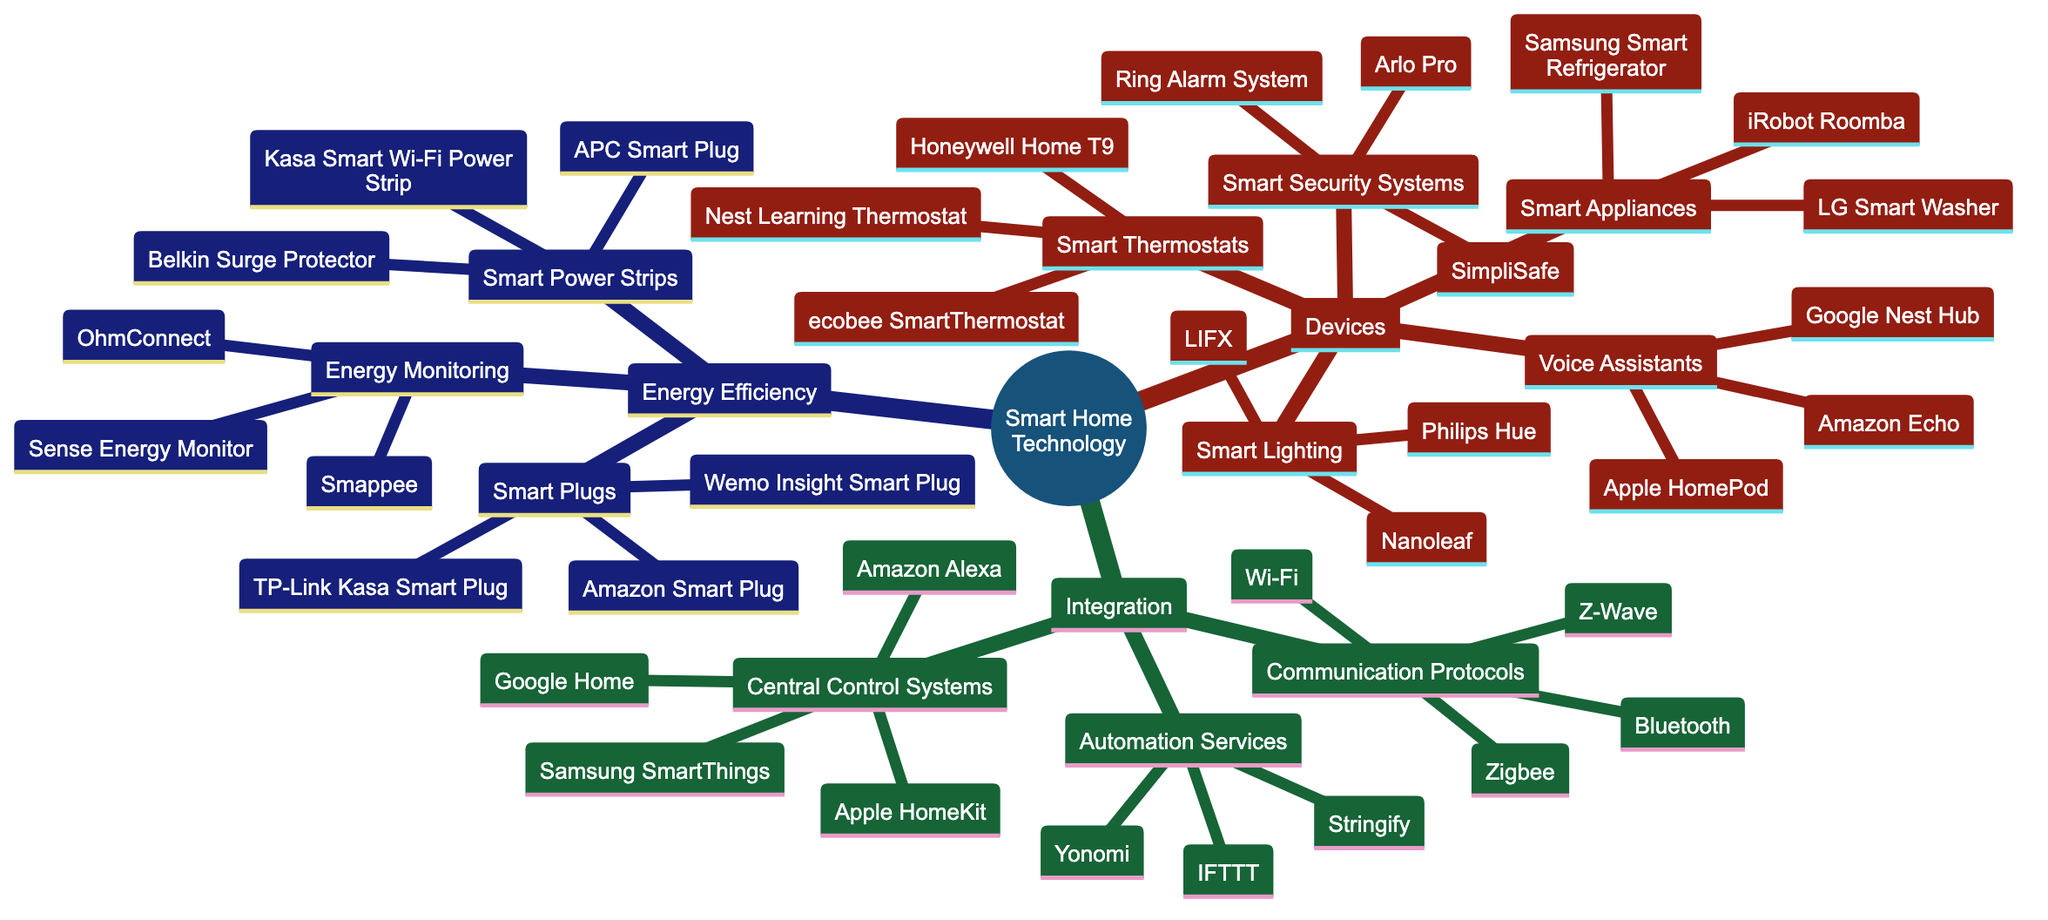What types of devices are listed under Smart Home Technology? The diagram has a main branch labeled 'Devices,' which includes categories like Smart Lighting, Smart Thermostats, Smart Security Systems, Smart Appliances, and Voice Assistants.
Answer: Smart Lighting, Smart Thermostats, Smart Security Systems, Smart Appliances, Voice Assistants How many brands are listed under Smart Lighting? Under the Smart Lighting branch, there are three devices mentioned: Philips Hue, LIFX, and Nanoleaf. Thus, you count these three to find the answer.
Answer: 3 What is the total number of Central Control Systems listed? The Central Control Systems branch contains four systems: Apple HomeKit, Samsung SmartThings, Amazon Alexa, and Google Home. Counting these gives the total number.
Answer: 4 Which communication protocol is common in smart home integration? The Integration section lists multiple communication protocols, and one of the most common mentioned is Wi-Fi, along with Zigbee, Z-Wave, and Bluetooth. Since Wi-Fi is specifically listed, it is the answer.
Answer: Wi-Fi Which type of smart device involves energy monitoring? In the Energy Efficiency section, the Energy Monitoring category mentions devices like Sense Energy Monitor, OhmConnect, and Smappee, indicating that this type is specifically related to energy monitoring.
Answer: Energy Monitoring What are the brands associated with Smart Appliances? The Smart Appliances branch under Devices has three specific brands listed: Samsung Smart Refrigerator, LG Smart Washer, and iRobot Roomba. You simply refer to this branch to answer.
Answer: Samsung Smart Refrigerator, LG Smart Washer, iRobot Roomba How many different types of Smart Plugs are listed? The Smart Efficiency section under Smart Plugs mentions three devices: TP-Link Kasa Smart Plug, Amazon Smart Plug, and Wemo Insight Smart Plug, so counting these provides the answer.
Answer: 3 Which automation service is part of the Smart Home Integration? Automation Services include three items: IFTTT, Yonomi, and Stringify. One example of an automation service here is IFTTT, which is a well-known platform.
Answer: IFTTT What is the link between Energy Efficiency and Smart Plugs in the diagram? Energy Efficiency features Smart Plugs as one of its branches. Smart Plugs are interconnected with energy savings and smart technology, as they facilitate the control of power usage.
Answer: Smart Plugs are under Energy Efficiency 